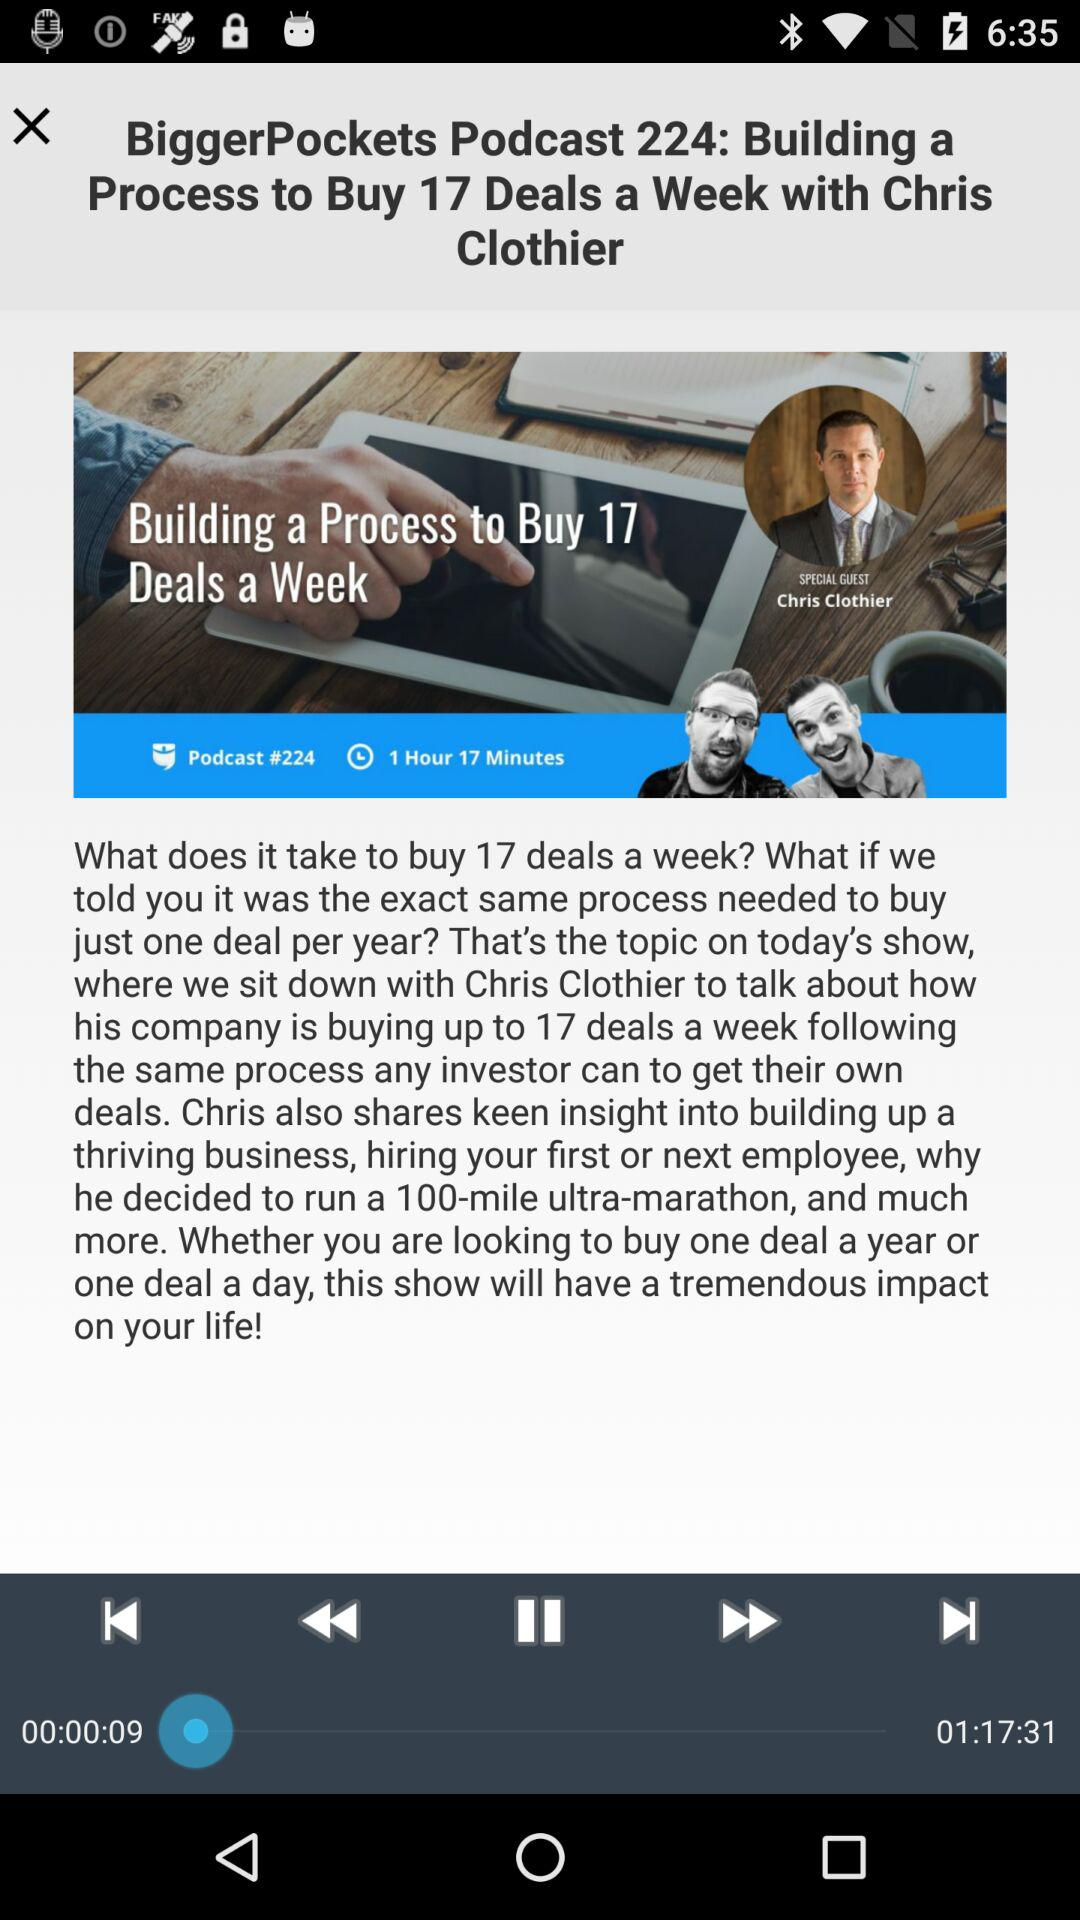What is the name of the show? The name of the show is "Building a Process to Buy 17 Deals a Week with Chris Clothier". 